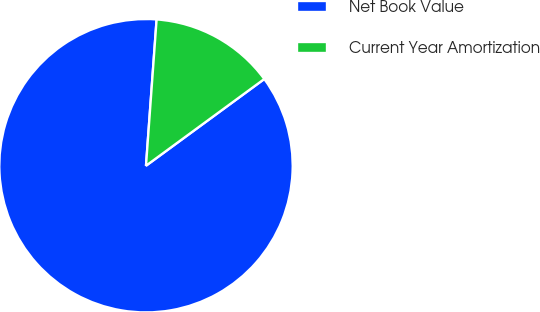<chart> <loc_0><loc_0><loc_500><loc_500><pie_chart><fcel>Net Book Value<fcel>Current Year Amortization<nl><fcel>86.22%<fcel>13.78%<nl></chart> 